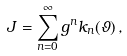<formula> <loc_0><loc_0><loc_500><loc_500>J = \sum _ { n = 0 } ^ { \infty } g ^ { n } k _ { n } ( \vartheta ) \, ,</formula> 